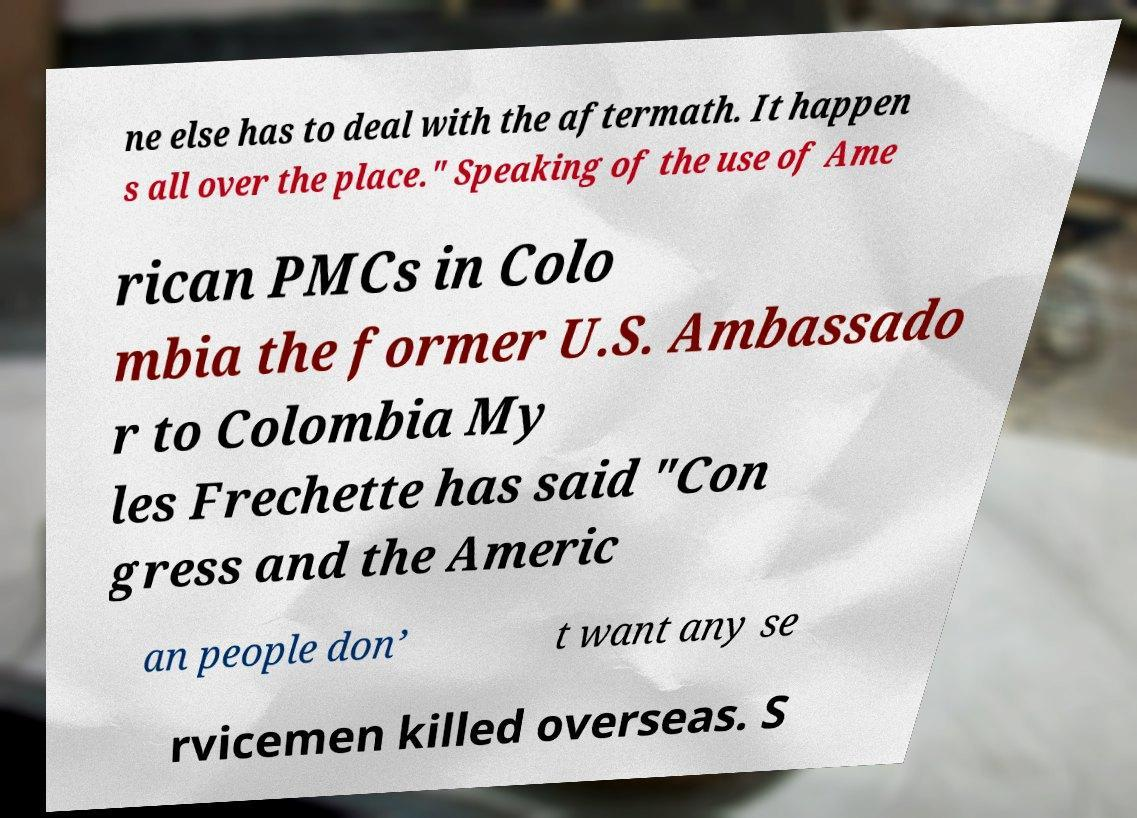Please identify and transcribe the text found in this image. ne else has to deal with the aftermath. It happen s all over the place." Speaking of the use of Ame rican PMCs in Colo mbia the former U.S. Ambassado r to Colombia My les Frechette has said "Con gress and the Americ an people don’ t want any se rvicemen killed overseas. S 